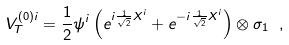Convert formula to latex. <formula><loc_0><loc_0><loc_500><loc_500>V _ { T } ^ { ( 0 ) i } = \frac { 1 } { 2 } \psi ^ { i } \left ( e ^ { i \frac { 1 } { \sqrt { 2 } } X ^ { i } } + e ^ { - i \frac { 1 } { \sqrt { 2 } } X ^ { i } } \right ) \otimes \sigma _ { 1 } \ ,</formula> 